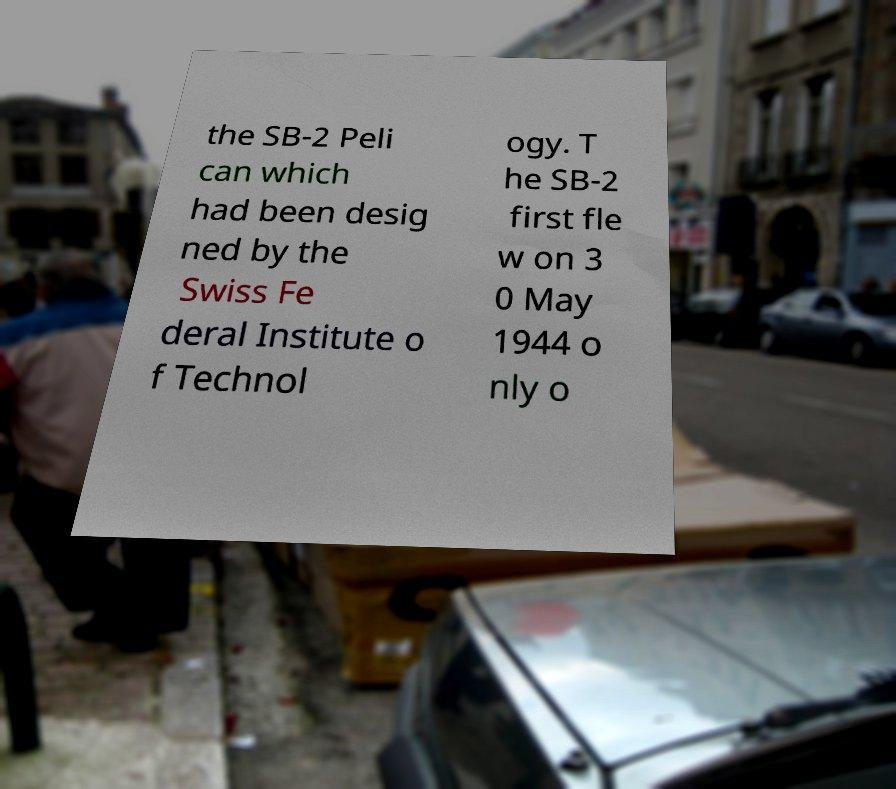There's text embedded in this image that I need extracted. Can you transcribe it verbatim? the SB-2 Peli can which had been desig ned by the Swiss Fe deral Institute o f Technol ogy. T he SB-2 first fle w on 3 0 May 1944 o nly o 